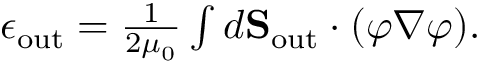<formula> <loc_0><loc_0><loc_500><loc_500>\begin{array} { r } { \epsilon _ { o u t } = \frac { 1 } { 2 \mu _ { 0 } } \int d { S } _ { o u t } \cdot ( \varphi \nabla \varphi ) . } \end{array}</formula> 